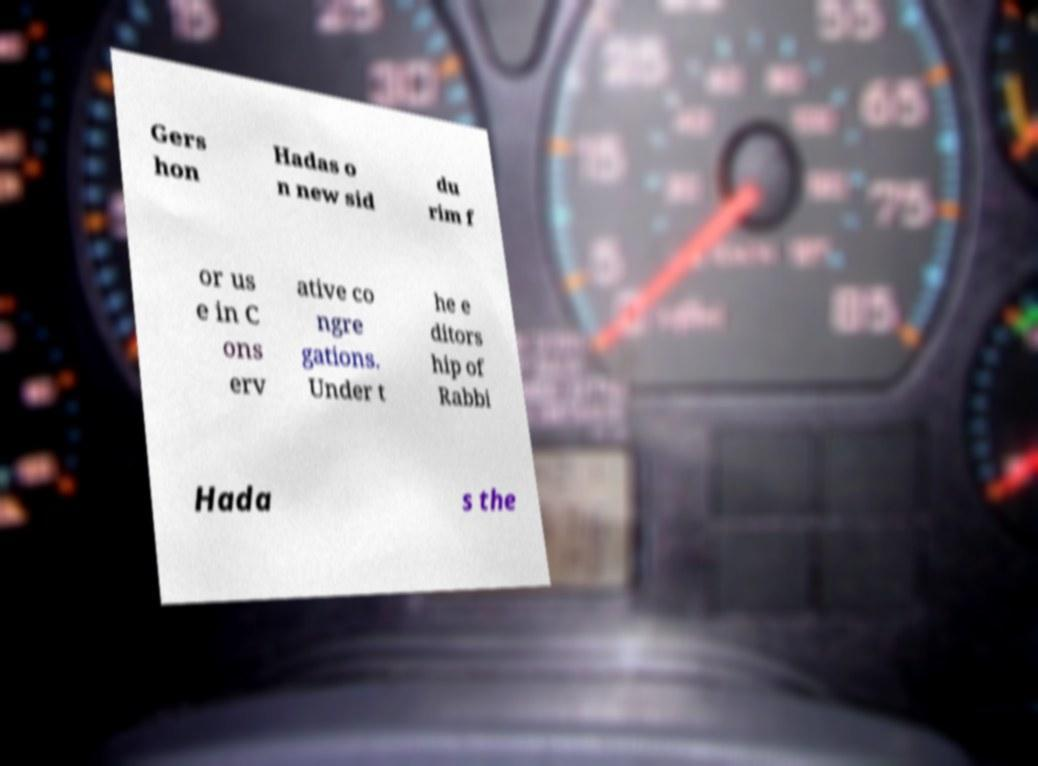For documentation purposes, I need the text within this image transcribed. Could you provide that? Gers hon Hadas o n new sid du rim f or us e in C ons erv ative co ngre gations. Under t he e ditors hip of Rabbi Hada s the 